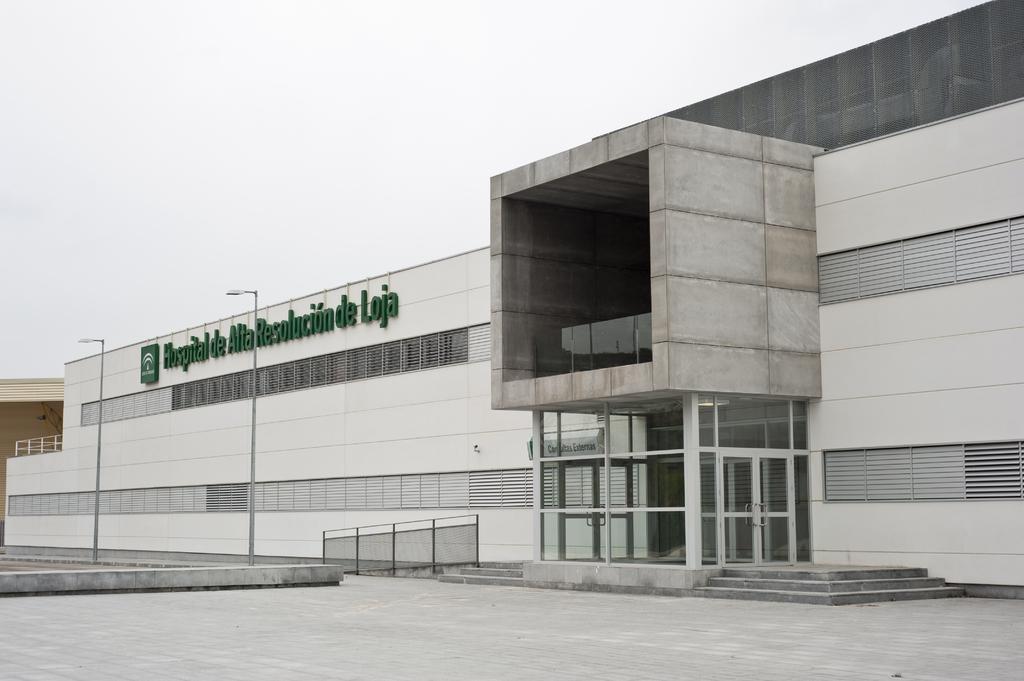Can you describe this image briefly? This picture is clicked outside. In the foreground we can see the ground and the street lights attached to the poles. In the center there is a building and we can see the text on the building. In the background there is a sky and we can see the metal rods and the stairs and the windows. 